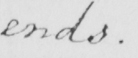What is written in this line of handwriting? ends . 